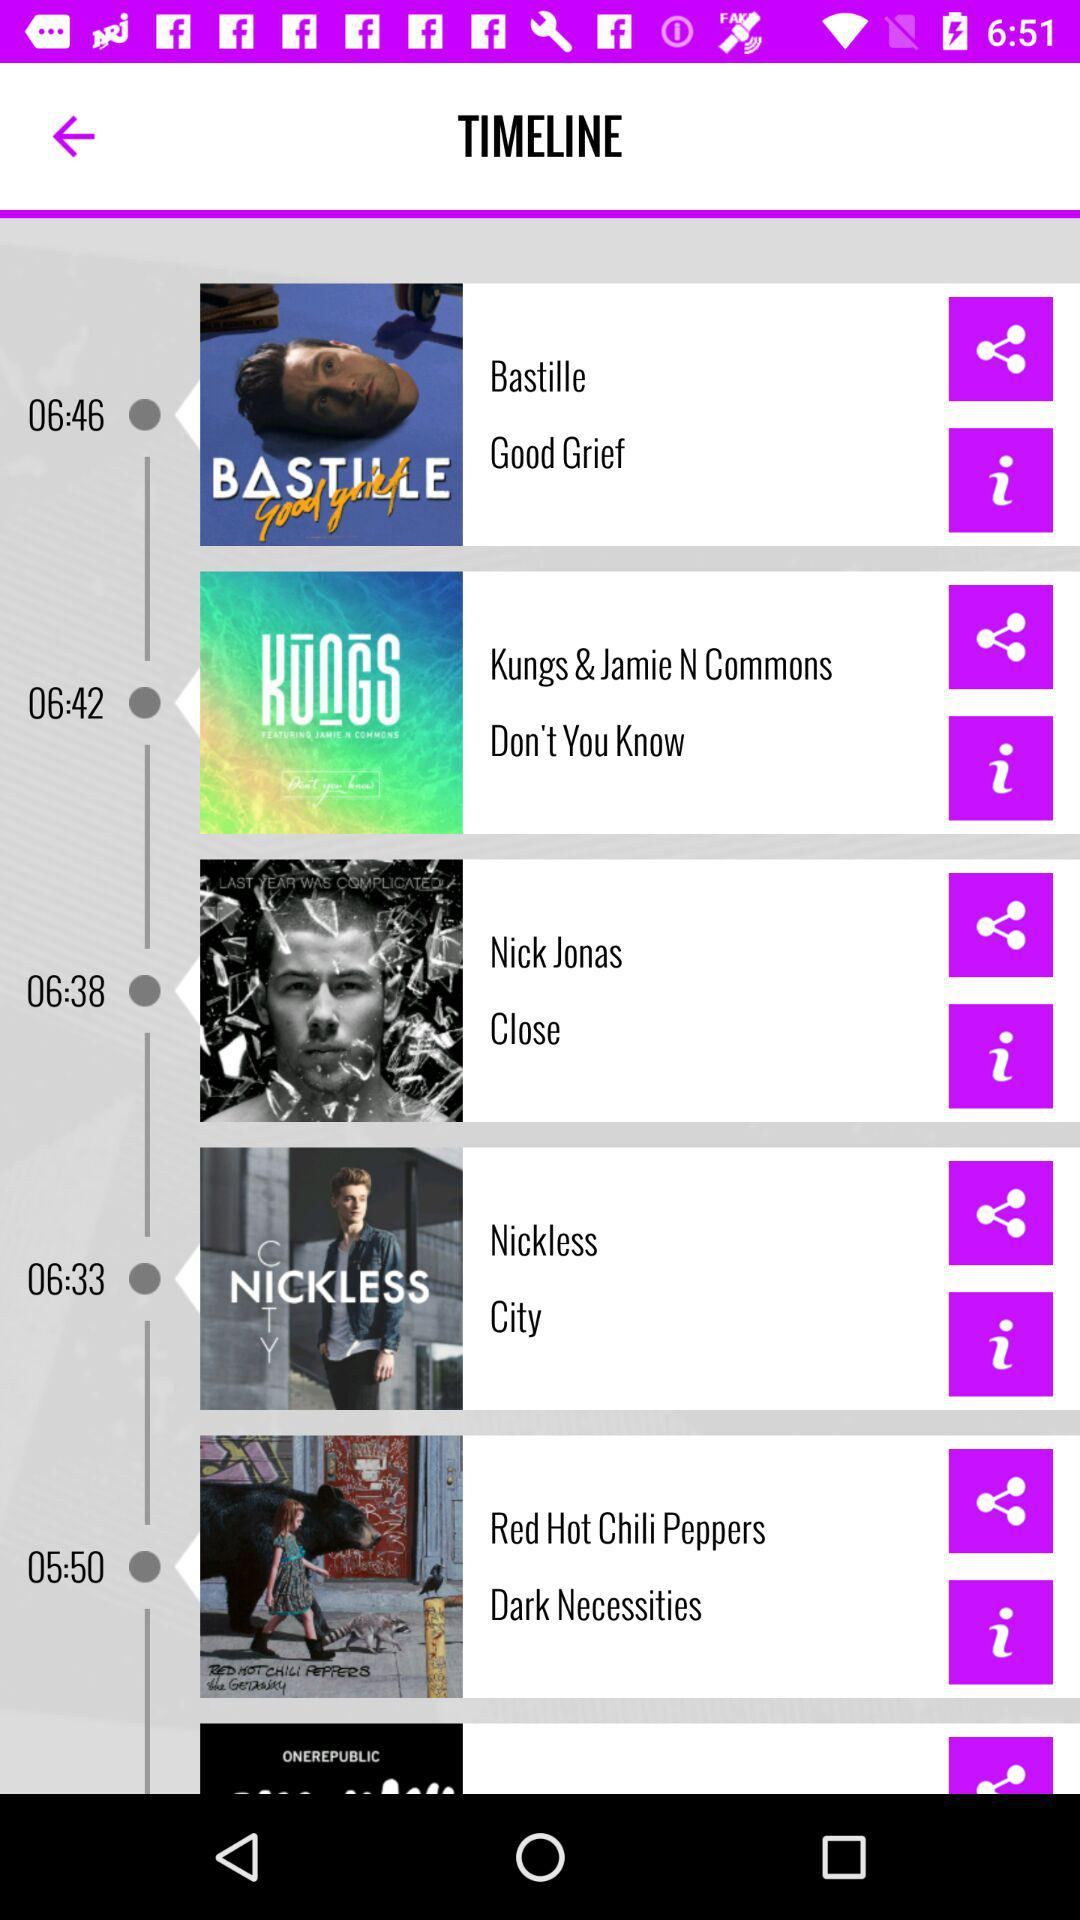What is the mentioned time for the song named "City"? The mentioned time is 06:33. 